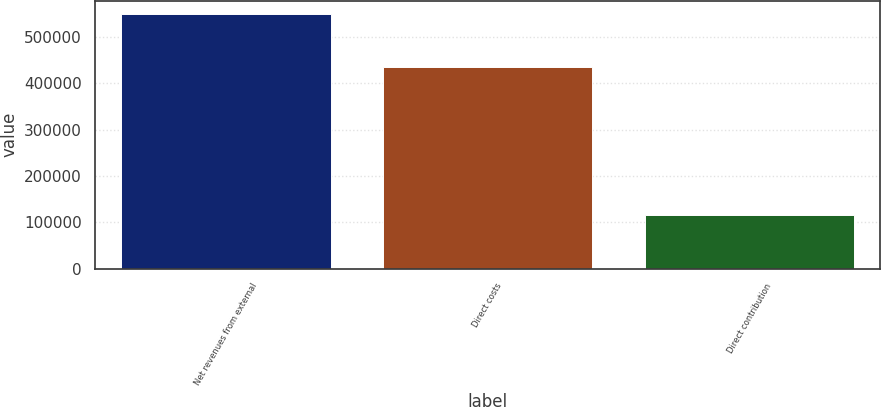Convert chart to OTSL. <chart><loc_0><loc_0><loc_500><loc_500><bar_chart><fcel>Net revenues from external<fcel>Direct costs<fcel>Direct contribution<nl><fcel>550841<fcel>434588<fcel>116253<nl></chart> 